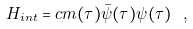<formula> <loc_0><loc_0><loc_500><loc_500>H _ { i n t } = c m ( \tau ) \bar { \psi } ( \tau ) \psi ( \tau ) \ ,</formula> 